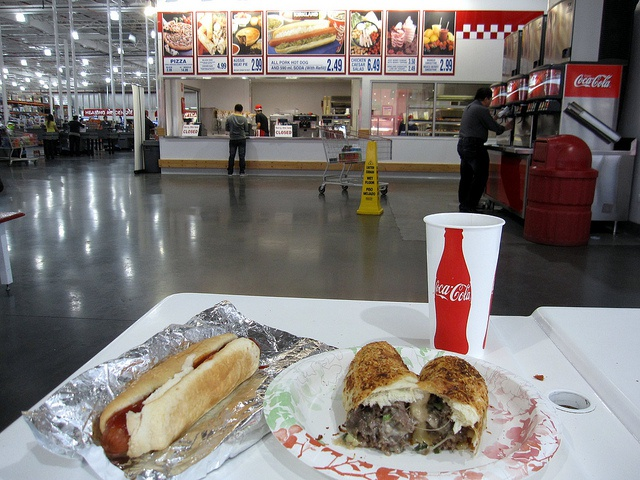Describe the objects in this image and their specific colors. I can see dining table in gray, lightgray, darkgray, and tan tones, hot dog in gray, tan, beige, and darkgray tones, cup in gray, lightgray, brown, and darkgray tones, dining table in gray, lightgray, and darkgray tones, and sandwich in gray, olive, maroon, and tan tones in this image. 